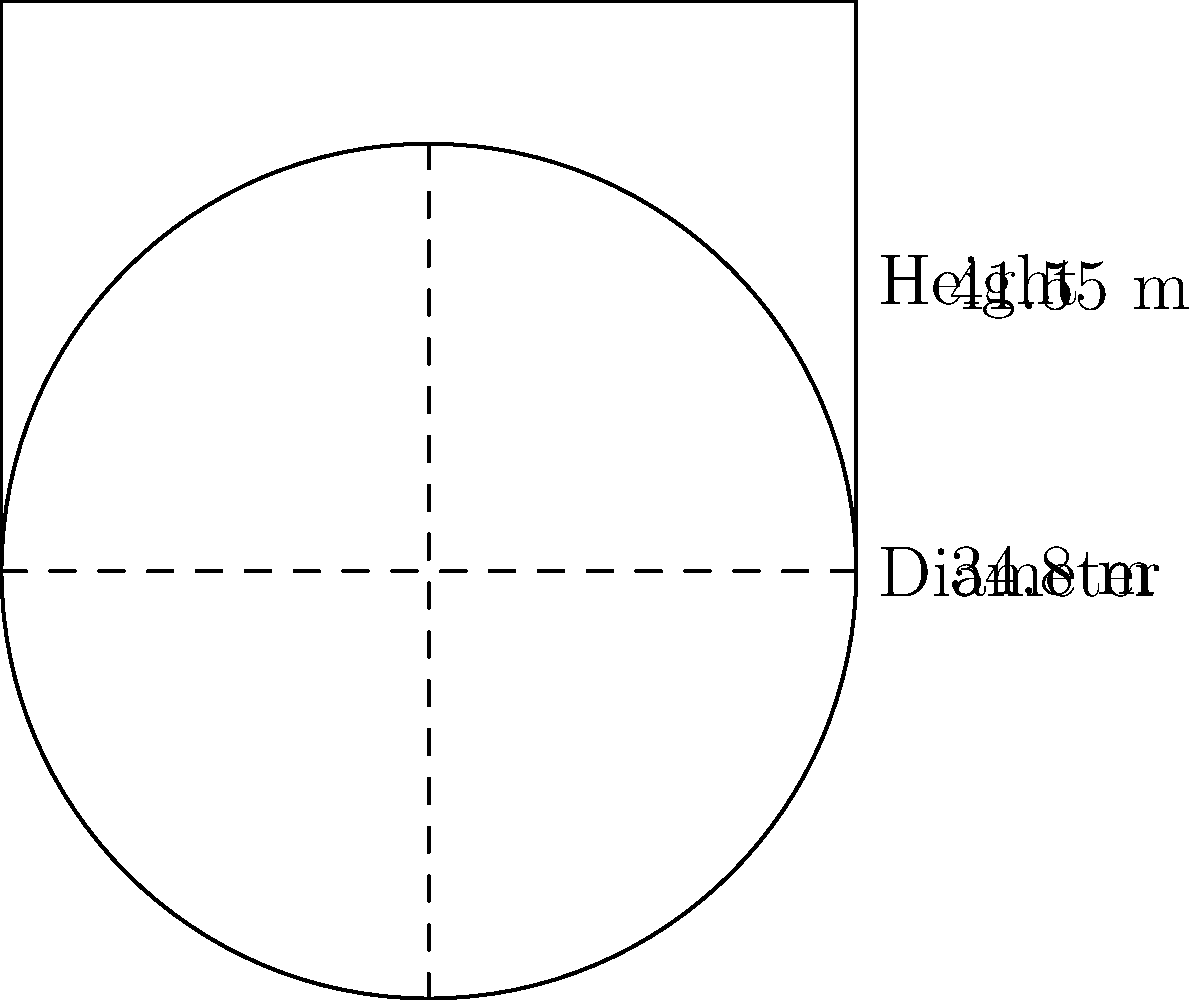The Rundetaarn (Round Tower) in Copenhagen has a circular floor plan with a diameter of 34.8 meters and a height of 41.55 meters. If you were to create a scale model of the tower with a base diameter of 20 cm, what would be the height of your model in centimeters? Round your answer to the nearest centimeter. To solve this problem, we need to use the concept of scale and proportion. Let's break it down step by step:

1. Understand the given information:
   - Actual diameter of Rundetaarn: 34.8 meters
   - Actual height of Rundetaarn: 41.55 meters
   - Model diameter: 20 cm

2. Calculate the scale factor:
   The scale factor is the ratio of the model size to the actual size.
   Scale factor = Model diameter / Actual diameter
   $$ \text{Scale factor} = \frac{20 \text{ cm}}{34.8 \text{ m}} = \frac{20 \text{ cm}}{3480 \text{ cm}} = \frac{1}{174} $$

3. Use the scale factor to calculate the model height:
   $$ \text{Model height} = \text{Actual height} \times \text{Scale factor} $$
   $$ \text{Model height} = 41.55 \text{ m} \times \frac{1}{174} $$
   $$ \text{Model height} = 4155 \text{ cm} \times \frac{1}{174} $$
   $$ \text{Model height} = 23.88 \text{ cm} $$

4. Round the result to the nearest centimeter:
   23.88 cm rounds to 24 cm

Therefore, the height of the scale model would be 24 cm.
Answer: 24 cm 